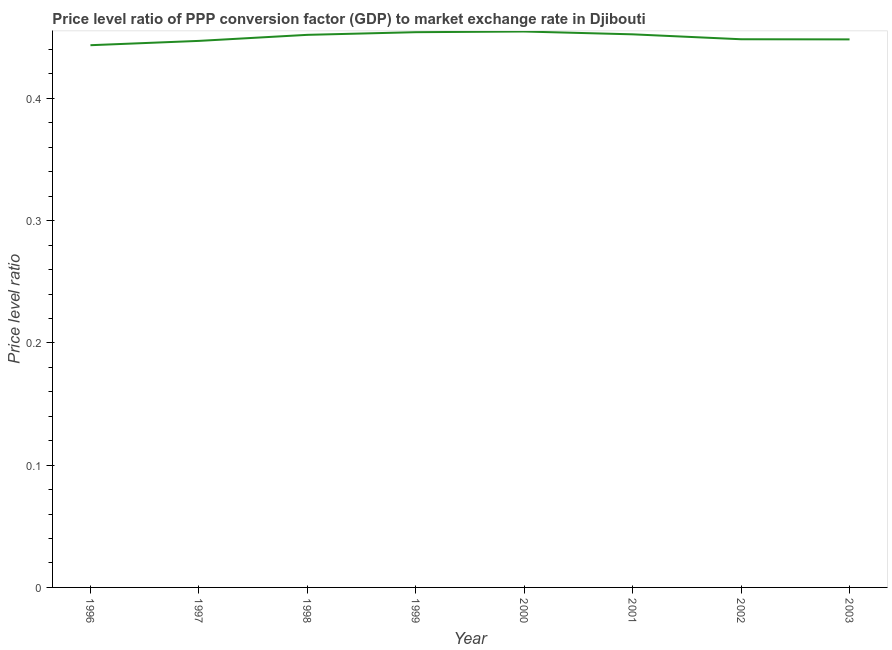What is the price level ratio in 1999?
Offer a very short reply. 0.45. Across all years, what is the maximum price level ratio?
Provide a short and direct response. 0.45. Across all years, what is the minimum price level ratio?
Your answer should be very brief. 0.44. What is the sum of the price level ratio?
Provide a short and direct response. 3.6. What is the difference between the price level ratio in 1999 and 2003?
Provide a succinct answer. 0.01. What is the average price level ratio per year?
Provide a succinct answer. 0.45. What is the median price level ratio?
Give a very brief answer. 0.45. What is the ratio of the price level ratio in 1998 to that in 2000?
Your answer should be very brief. 0.99. Is the price level ratio in 2000 less than that in 2003?
Your answer should be compact. No. What is the difference between the highest and the second highest price level ratio?
Offer a very short reply. 0. What is the difference between the highest and the lowest price level ratio?
Offer a very short reply. 0.01. In how many years, is the price level ratio greater than the average price level ratio taken over all years?
Make the answer very short. 4. Does the price level ratio monotonically increase over the years?
Provide a short and direct response. No. What is the difference between two consecutive major ticks on the Y-axis?
Your answer should be very brief. 0.1. Are the values on the major ticks of Y-axis written in scientific E-notation?
Your response must be concise. No. What is the title of the graph?
Your answer should be very brief. Price level ratio of PPP conversion factor (GDP) to market exchange rate in Djibouti. What is the label or title of the X-axis?
Offer a very short reply. Year. What is the label or title of the Y-axis?
Keep it short and to the point. Price level ratio. What is the Price level ratio in 1996?
Provide a succinct answer. 0.44. What is the Price level ratio in 1997?
Ensure brevity in your answer.  0.45. What is the Price level ratio of 1998?
Your answer should be very brief. 0.45. What is the Price level ratio in 1999?
Provide a succinct answer. 0.45. What is the Price level ratio in 2000?
Give a very brief answer. 0.45. What is the Price level ratio of 2001?
Your answer should be very brief. 0.45. What is the Price level ratio in 2002?
Ensure brevity in your answer.  0.45. What is the Price level ratio in 2003?
Provide a succinct answer. 0.45. What is the difference between the Price level ratio in 1996 and 1997?
Give a very brief answer. -0. What is the difference between the Price level ratio in 1996 and 1998?
Your answer should be very brief. -0.01. What is the difference between the Price level ratio in 1996 and 1999?
Provide a short and direct response. -0.01. What is the difference between the Price level ratio in 1996 and 2000?
Ensure brevity in your answer.  -0.01. What is the difference between the Price level ratio in 1996 and 2001?
Your response must be concise. -0.01. What is the difference between the Price level ratio in 1996 and 2002?
Your answer should be very brief. -0. What is the difference between the Price level ratio in 1996 and 2003?
Make the answer very short. -0. What is the difference between the Price level ratio in 1997 and 1998?
Your answer should be compact. -0. What is the difference between the Price level ratio in 1997 and 1999?
Offer a terse response. -0.01. What is the difference between the Price level ratio in 1997 and 2000?
Your answer should be very brief. -0.01. What is the difference between the Price level ratio in 1997 and 2001?
Your answer should be very brief. -0.01. What is the difference between the Price level ratio in 1997 and 2002?
Your answer should be very brief. -0. What is the difference between the Price level ratio in 1997 and 2003?
Your response must be concise. -0. What is the difference between the Price level ratio in 1998 and 1999?
Offer a terse response. -0. What is the difference between the Price level ratio in 1998 and 2000?
Ensure brevity in your answer.  -0. What is the difference between the Price level ratio in 1998 and 2001?
Keep it short and to the point. -0. What is the difference between the Price level ratio in 1998 and 2002?
Your answer should be compact. 0. What is the difference between the Price level ratio in 1998 and 2003?
Provide a succinct answer. 0. What is the difference between the Price level ratio in 1999 and 2000?
Provide a short and direct response. -0. What is the difference between the Price level ratio in 1999 and 2001?
Offer a terse response. 0. What is the difference between the Price level ratio in 1999 and 2002?
Your answer should be very brief. 0.01. What is the difference between the Price level ratio in 1999 and 2003?
Provide a succinct answer. 0.01. What is the difference between the Price level ratio in 2000 and 2001?
Provide a succinct answer. 0. What is the difference between the Price level ratio in 2000 and 2002?
Ensure brevity in your answer.  0.01. What is the difference between the Price level ratio in 2000 and 2003?
Provide a succinct answer. 0.01. What is the difference between the Price level ratio in 2001 and 2002?
Keep it short and to the point. 0. What is the difference between the Price level ratio in 2001 and 2003?
Keep it short and to the point. 0. What is the difference between the Price level ratio in 2002 and 2003?
Your answer should be very brief. 0. What is the ratio of the Price level ratio in 1996 to that in 1998?
Your answer should be very brief. 0.98. What is the ratio of the Price level ratio in 1996 to that in 2000?
Your answer should be very brief. 0.97. What is the ratio of the Price level ratio in 1996 to that in 2001?
Offer a terse response. 0.98. What is the ratio of the Price level ratio in 1996 to that in 2002?
Ensure brevity in your answer.  0.99. What is the ratio of the Price level ratio in 1996 to that in 2003?
Keep it short and to the point. 0.99. What is the ratio of the Price level ratio in 1997 to that in 1999?
Provide a succinct answer. 0.98. What is the ratio of the Price level ratio in 1997 to that in 2001?
Make the answer very short. 0.99. What is the ratio of the Price level ratio in 1997 to that in 2002?
Provide a succinct answer. 1. What is the ratio of the Price level ratio in 1997 to that in 2003?
Your answer should be very brief. 1. What is the ratio of the Price level ratio in 1999 to that in 2000?
Offer a very short reply. 1. What is the ratio of the Price level ratio in 1999 to that in 2002?
Give a very brief answer. 1.01. What is the ratio of the Price level ratio in 1999 to that in 2003?
Your answer should be very brief. 1.01. 